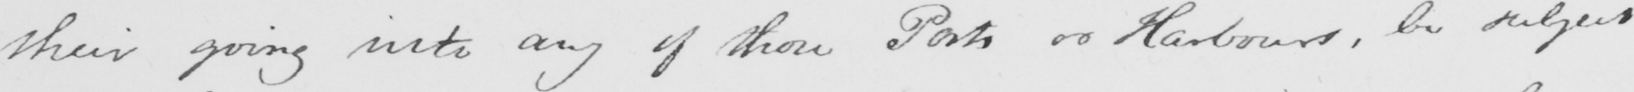Transcribe the text shown in this historical manuscript line. their going into any of those Ports or Harbours , be subject 